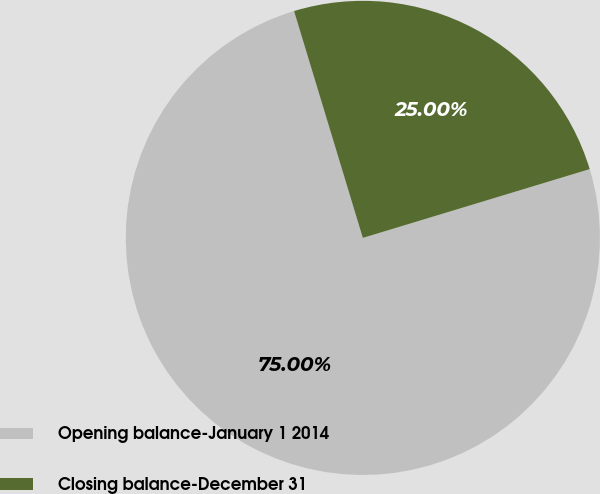Convert chart. <chart><loc_0><loc_0><loc_500><loc_500><pie_chart><fcel>Opening balance-January 1 2014<fcel>Closing balance-December 31<nl><fcel>75.0%<fcel>25.0%<nl></chart> 